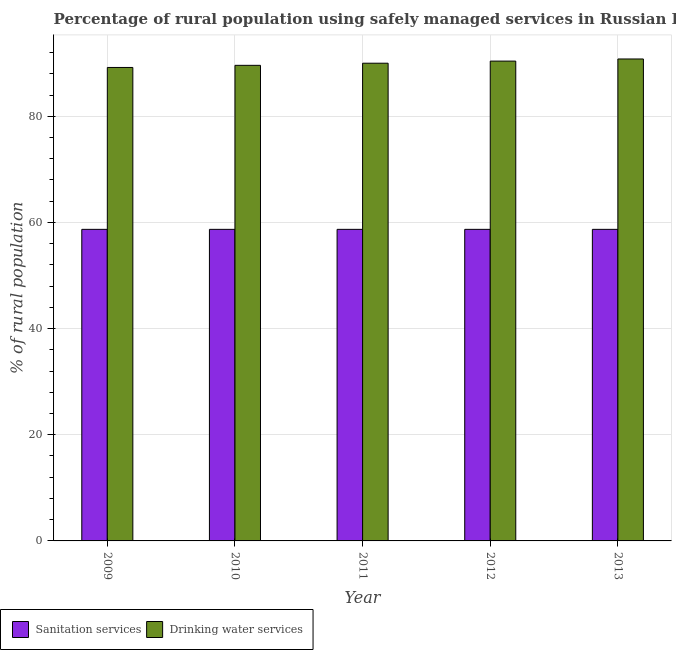How many groups of bars are there?
Your answer should be very brief. 5. Are the number of bars per tick equal to the number of legend labels?
Make the answer very short. Yes. Are the number of bars on each tick of the X-axis equal?
Offer a very short reply. Yes. How many bars are there on the 5th tick from the left?
Offer a terse response. 2. How many bars are there on the 3rd tick from the right?
Make the answer very short. 2. In how many cases, is the number of bars for a given year not equal to the number of legend labels?
Your response must be concise. 0. What is the percentage of rural population who used sanitation services in 2010?
Offer a very short reply. 58.7. Across all years, what is the maximum percentage of rural population who used drinking water services?
Provide a short and direct response. 90.8. Across all years, what is the minimum percentage of rural population who used drinking water services?
Your answer should be very brief. 89.2. In which year was the percentage of rural population who used drinking water services maximum?
Ensure brevity in your answer.  2013. In which year was the percentage of rural population who used drinking water services minimum?
Your answer should be compact. 2009. What is the total percentage of rural population who used drinking water services in the graph?
Give a very brief answer. 450. What is the difference between the percentage of rural population who used drinking water services in 2012 and that in 2013?
Make the answer very short. -0.4. What is the difference between the percentage of rural population who used drinking water services in 2012 and the percentage of rural population who used sanitation services in 2011?
Your answer should be very brief. 0.4. What is the average percentage of rural population who used drinking water services per year?
Provide a succinct answer. 90. In the year 2009, what is the difference between the percentage of rural population who used drinking water services and percentage of rural population who used sanitation services?
Give a very brief answer. 0. What is the ratio of the percentage of rural population who used drinking water services in 2012 to that in 2013?
Offer a very short reply. 1. Is the percentage of rural population who used drinking water services in 2010 less than that in 2012?
Provide a short and direct response. Yes. What is the difference between the highest and the second highest percentage of rural population who used drinking water services?
Your answer should be very brief. 0.4. What is the difference between the highest and the lowest percentage of rural population who used sanitation services?
Offer a terse response. 0. In how many years, is the percentage of rural population who used sanitation services greater than the average percentage of rural population who used sanitation services taken over all years?
Your answer should be very brief. 0. What does the 1st bar from the left in 2013 represents?
Ensure brevity in your answer.  Sanitation services. What does the 1st bar from the right in 2011 represents?
Your answer should be compact. Drinking water services. Are all the bars in the graph horizontal?
Give a very brief answer. No. How many years are there in the graph?
Provide a succinct answer. 5. What is the difference between two consecutive major ticks on the Y-axis?
Provide a short and direct response. 20. Does the graph contain grids?
Make the answer very short. Yes. Where does the legend appear in the graph?
Give a very brief answer. Bottom left. What is the title of the graph?
Offer a terse response. Percentage of rural population using safely managed services in Russian Federation. Does "Drinking water services" appear as one of the legend labels in the graph?
Provide a short and direct response. Yes. What is the label or title of the X-axis?
Provide a short and direct response. Year. What is the label or title of the Y-axis?
Ensure brevity in your answer.  % of rural population. What is the % of rural population in Sanitation services in 2009?
Provide a succinct answer. 58.7. What is the % of rural population in Drinking water services in 2009?
Give a very brief answer. 89.2. What is the % of rural population in Sanitation services in 2010?
Your answer should be compact. 58.7. What is the % of rural population of Drinking water services in 2010?
Offer a terse response. 89.6. What is the % of rural population in Sanitation services in 2011?
Keep it short and to the point. 58.7. What is the % of rural population of Drinking water services in 2011?
Offer a very short reply. 90. What is the % of rural population in Sanitation services in 2012?
Give a very brief answer. 58.7. What is the % of rural population in Drinking water services in 2012?
Give a very brief answer. 90.4. What is the % of rural population of Sanitation services in 2013?
Give a very brief answer. 58.7. What is the % of rural population of Drinking water services in 2013?
Your answer should be very brief. 90.8. Across all years, what is the maximum % of rural population in Sanitation services?
Offer a very short reply. 58.7. Across all years, what is the maximum % of rural population in Drinking water services?
Your answer should be very brief. 90.8. Across all years, what is the minimum % of rural population of Sanitation services?
Provide a short and direct response. 58.7. Across all years, what is the minimum % of rural population in Drinking water services?
Ensure brevity in your answer.  89.2. What is the total % of rural population in Sanitation services in the graph?
Make the answer very short. 293.5. What is the total % of rural population in Drinking water services in the graph?
Make the answer very short. 450. What is the difference between the % of rural population in Sanitation services in 2009 and that in 2010?
Keep it short and to the point. 0. What is the difference between the % of rural population of Sanitation services in 2009 and that in 2011?
Provide a short and direct response. 0. What is the difference between the % of rural population of Drinking water services in 2009 and that in 2011?
Your answer should be compact. -0.8. What is the difference between the % of rural population of Sanitation services in 2009 and that in 2012?
Your answer should be compact. 0. What is the difference between the % of rural population of Drinking water services in 2009 and that in 2012?
Provide a short and direct response. -1.2. What is the difference between the % of rural population of Drinking water services in 2009 and that in 2013?
Ensure brevity in your answer.  -1.6. What is the difference between the % of rural population of Drinking water services in 2010 and that in 2011?
Your answer should be compact. -0.4. What is the difference between the % of rural population in Sanitation services in 2010 and that in 2012?
Offer a very short reply. 0. What is the difference between the % of rural population of Drinking water services in 2010 and that in 2012?
Your answer should be very brief. -0.8. What is the difference between the % of rural population in Drinking water services in 2010 and that in 2013?
Offer a very short reply. -1.2. What is the difference between the % of rural population in Sanitation services in 2011 and that in 2012?
Keep it short and to the point. 0. What is the difference between the % of rural population in Drinking water services in 2011 and that in 2012?
Offer a terse response. -0.4. What is the difference between the % of rural population of Sanitation services in 2011 and that in 2013?
Make the answer very short. 0. What is the difference between the % of rural population of Drinking water services in 2011 and that in 2013?
Ensure brevity in your answer.  -0.8. What is the difference between the % of rural population of Sanitation services in 2012 and that in 2013?
Your answer should be compact. 0. What is the difference between the % of rural population of Sanitation services in 2009 and the % of rural population of Drinking water services in 2010?
Keep it short and to the point. -30.9. What is the difference between the % of rural population of Sanitation services in 2009 and the % of rural population of Drinking water services in 2011?
Give a very brief answer. -31.3. What is the difference between the % of rural population in Sanitation services in 2009 and the % of rural population in Drinking water services in 2012?
Offer a terse response. -31.7. What is the difference between the % of rural population in Sanitation services in 2009 and the % of rural population in Drinking water services in 2013?
Your response must be concise. -32.1. What is the difference between the % of rural population in Sanitation services in 2010 and the % of rural population in Drinking water services in 2011?
Offer a very short reply. -31.3. What is the difference between the % of rural population of Sanitation services in 2010 and the % of rural population of Drinking water services in 2012?
Keep it short and to the point. -31.7. What is the difference between the % of rural population in Sanitation services in 2010 and the % of rural population in Drinking water services in 2013?
Offer a very short reply. -32.1. What is the difference between the % of rural population of Sanitation services in 2011 and the % of rural population of Drinking water services in 2012?
Provide a short and direct response. -31.7. What is the difference between the % of rural population of Sanitation services in 2011 and the % of rural population of Drinking water services in 2013?
Provide a succinct answer. -32.1. What is the difference between the % of rural population of Sanitation services in 2012 and the % of rural population of Drinking water services in 2013?
Offer a very short reply. -32.1. What is the average % of rural population in Sanitation services per year?
Give a very brief answer. 58.7. What is the average % of rural population of Drinking water services per year?
Your answer should be very brief. 90. In the year 2009, what is the difference between the % of rural population in Sanitation services and % of rural population in Drinking water services?
Provide a short and direct response. -30.5. In the year 2010, what is the difference between the % of rural population in Sanitation services and % of rural population in Drinking water services?
Offer a terse response. -30.9. In the year 2011, what is the difference between the % of rural population in Sanitation services and % of rural population in Drinking water services?
Keep it short and to the point. -31.3. In the year 2012, what is the difference between the % of rural population of Sanitation services and % of rural population of Drinking water services?
Your answer should be compact. -31.7. In the year 2013, what is the difference between the % of rural population of Sanitation services and % of rural population of Drinking water services?
Provide a succinct answer. -32.1. What is the ratio of the % of rural population of Drinking water services in 2009 to that in 2010?
Your answer should be very brief. 1. What is the ratio of the % of rural population in Sanitation services in 2009 to that in 2011?
Offer a terse response. 1. What is the ratio of the % of rural population of Drinking water services in 2009 to that in 2012?
Make the answer very short. 0.99. What is the ratio of the % of rural population of Sanitation services in 2009 to that in 2013?
Give a very brief answer. 1. What is the ratio of the % of rural population of Drinking water services in 2009 to that in 2013?
Provide a short and direct response. 0.98. What is the ratio of the % of rural population of Drinking water services in 2010 to that in 2011?
Your answer should be compact. 1. What is the ratio of the % of rural population of Drinking water services in 2010 to that in 2012?
Provide a short and direct response. 0.99. What is the ratio of the % of rural population of Sanitation services in 2010 to that in 2013?
Provide a short and direct response. 1. What is the ratio of the % of rural population of Sanitation services in 2011 to that in 2012?
Offer a very short reply. 1. What is the ratio of the % of rural population in Sanitation services in 2012 to that in 2013?
Keep it short and to the point. 1. What is the difference between the highest and the second highest % of rural population of Sanitation services?
Your answer should be very brief. 0. What is the difference between the highest and the second highest % of rural population of Drinking water services?
Your answer should be compact. 0.4. 